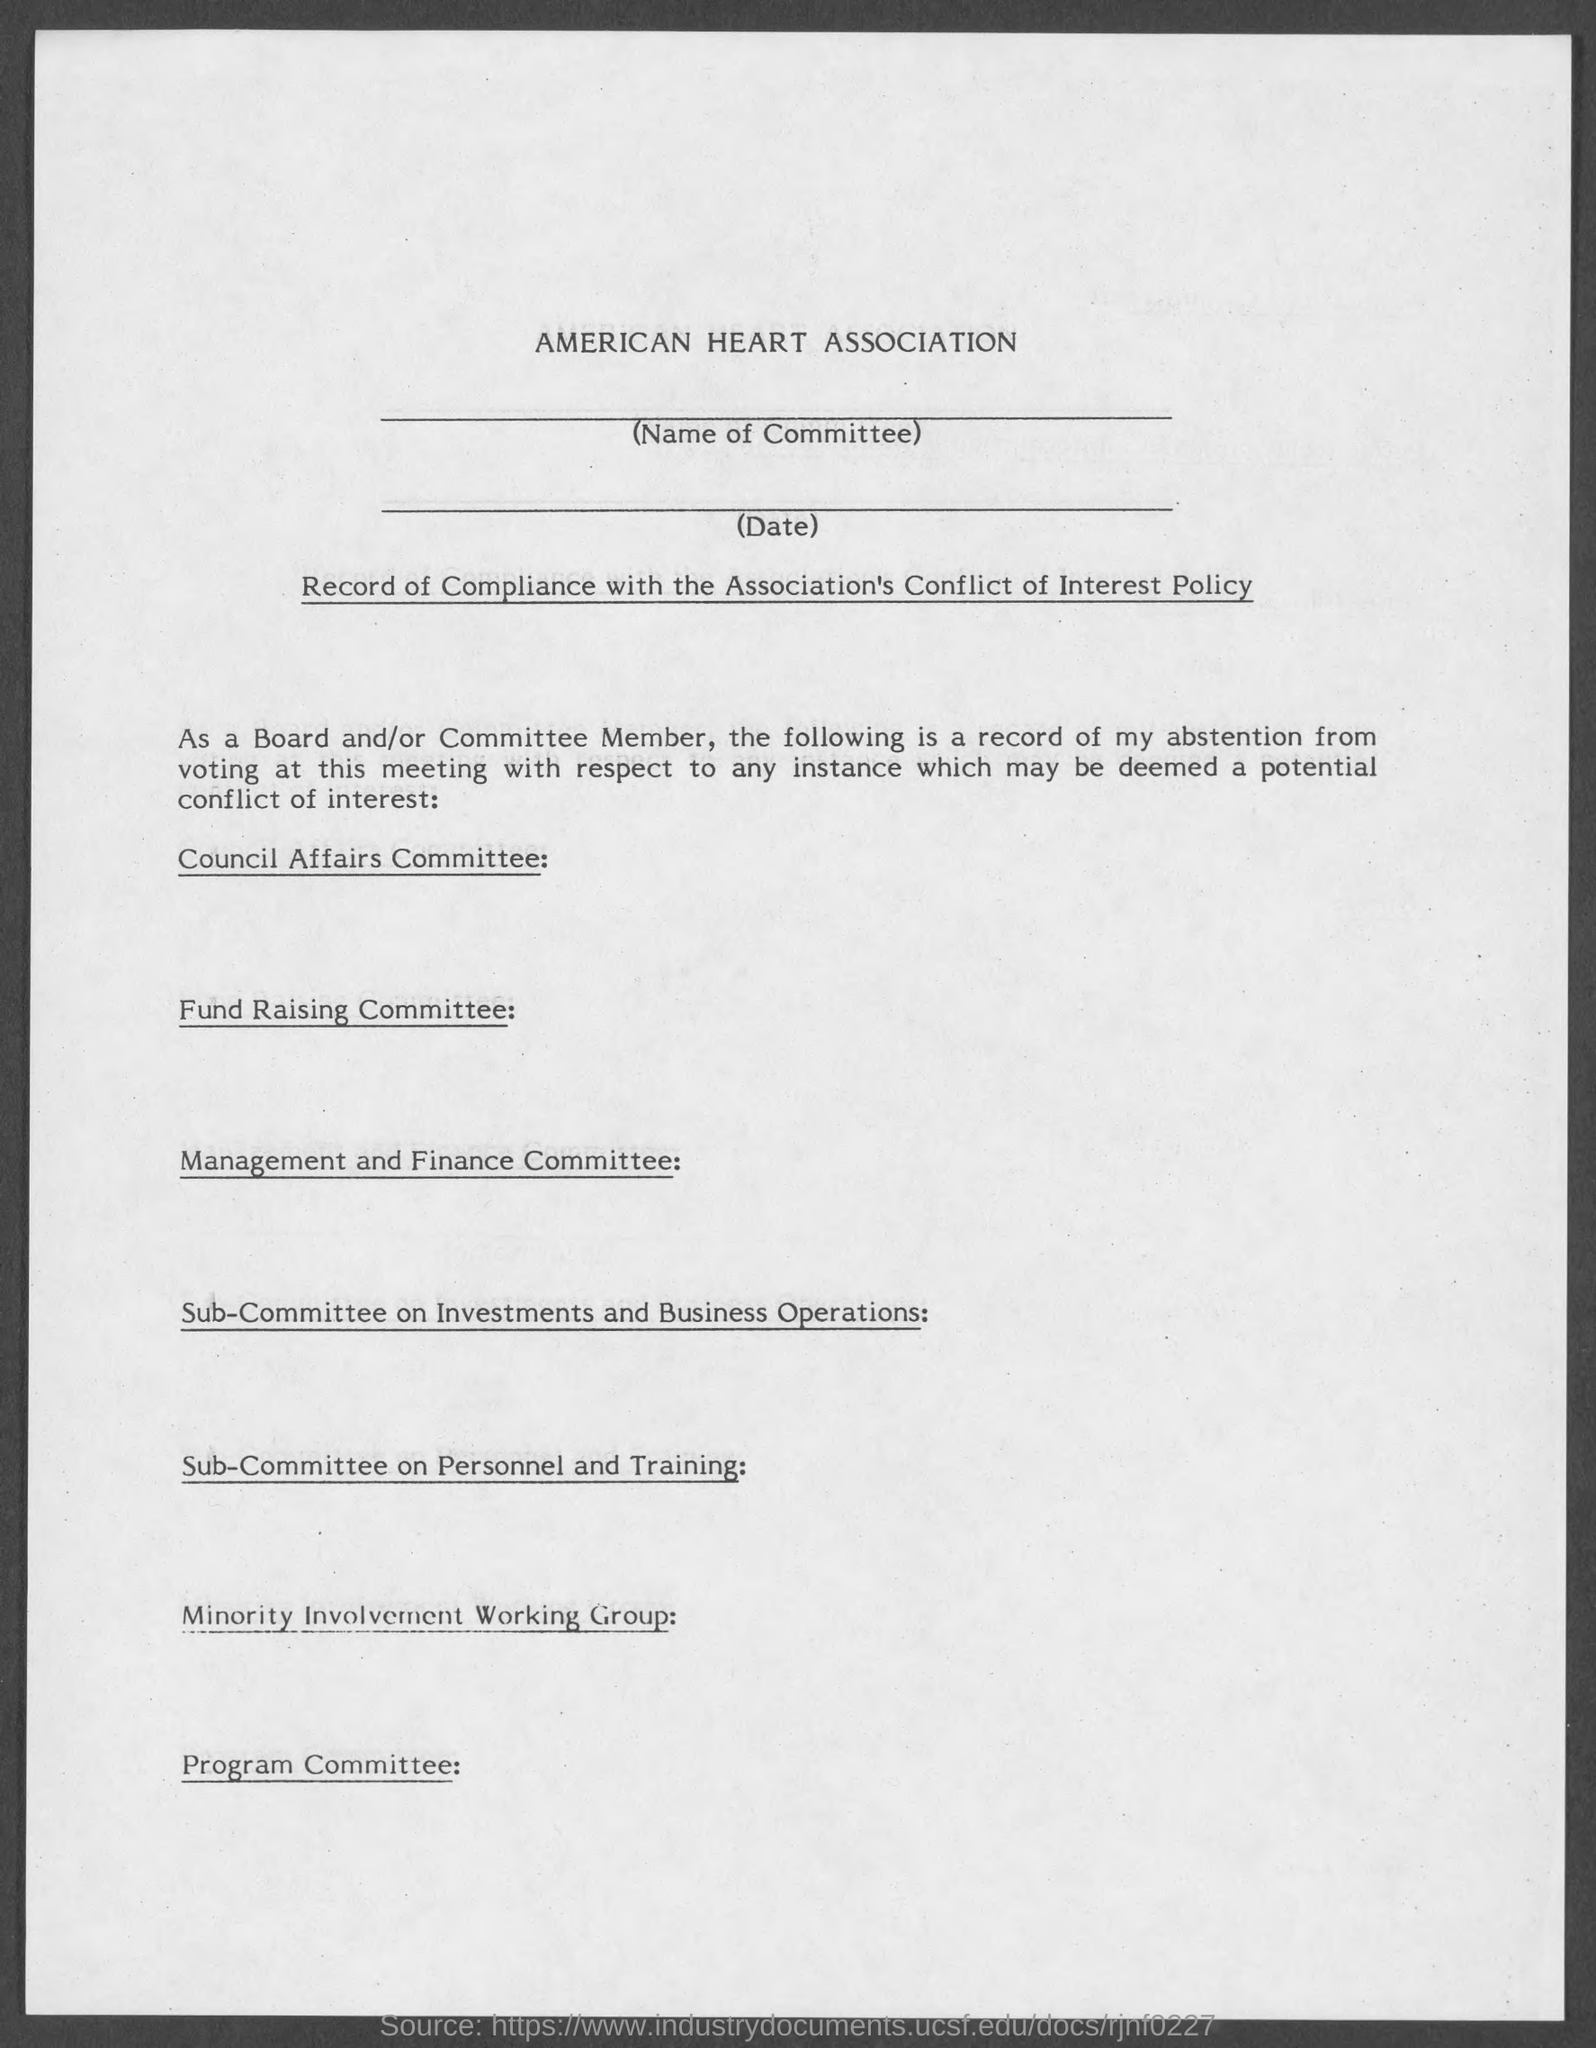What is the name of the association ?
Offer a terse response. American Heart Association. 